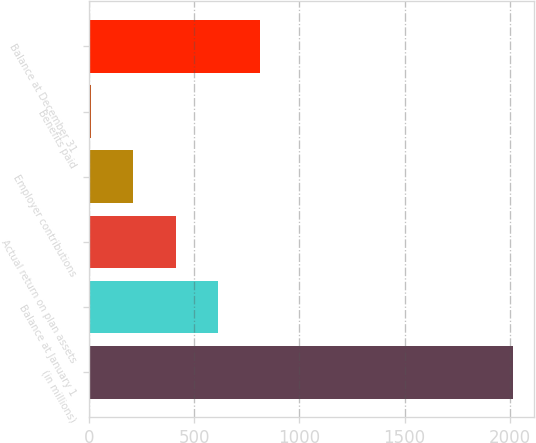Convert chart. <chart><loc_0><loc_0><loc_500><loc_500><bar_chart><fcel>(in millions)<fcel>Balance at January 1<fcel>Actual return on plan assets<fcel>Employer contributions<fcel>Benefits paid<fcel>Balance at December 31<nl><fcel>2016<fcel>611.59<fcel>410.96<fcel>210.33<fcel>9.7<fcel>812.22<nl></chart> 